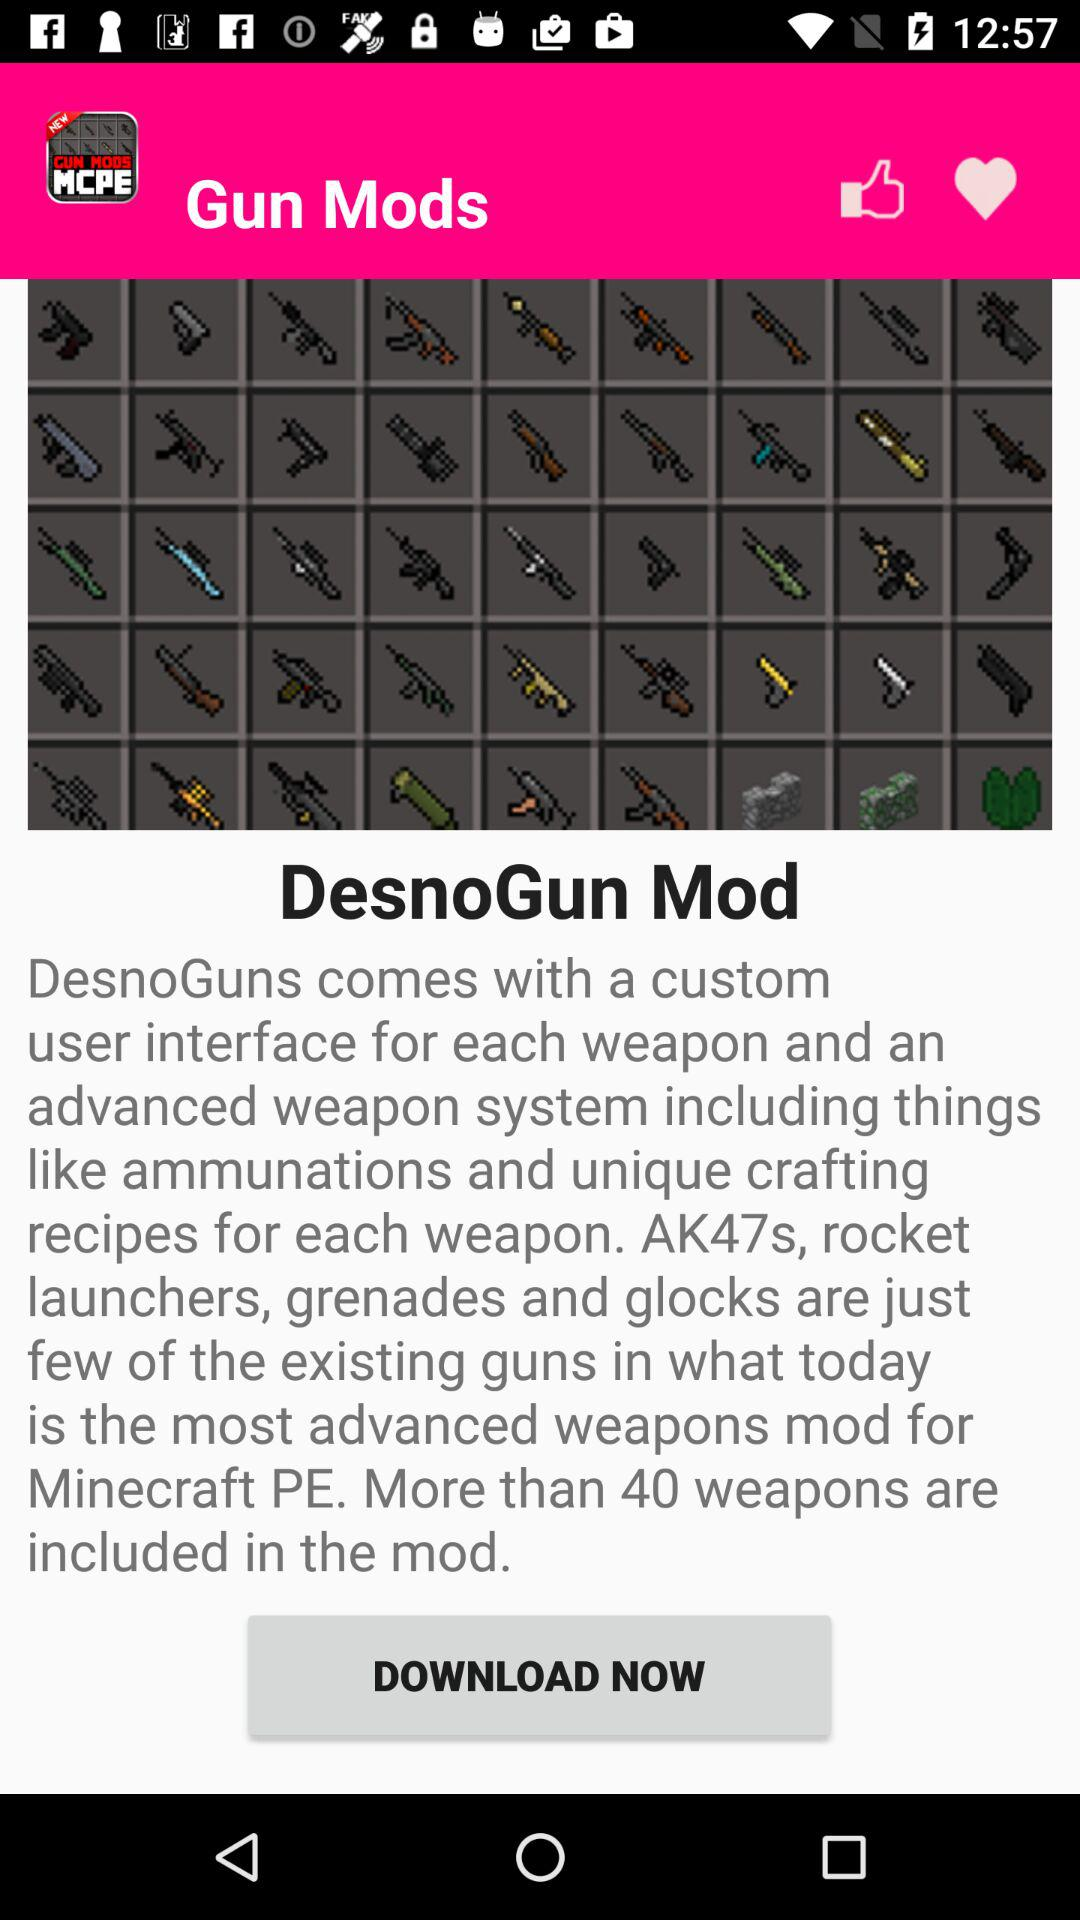What is the name of the application? The name of the application is "DesnoGun Mod". 